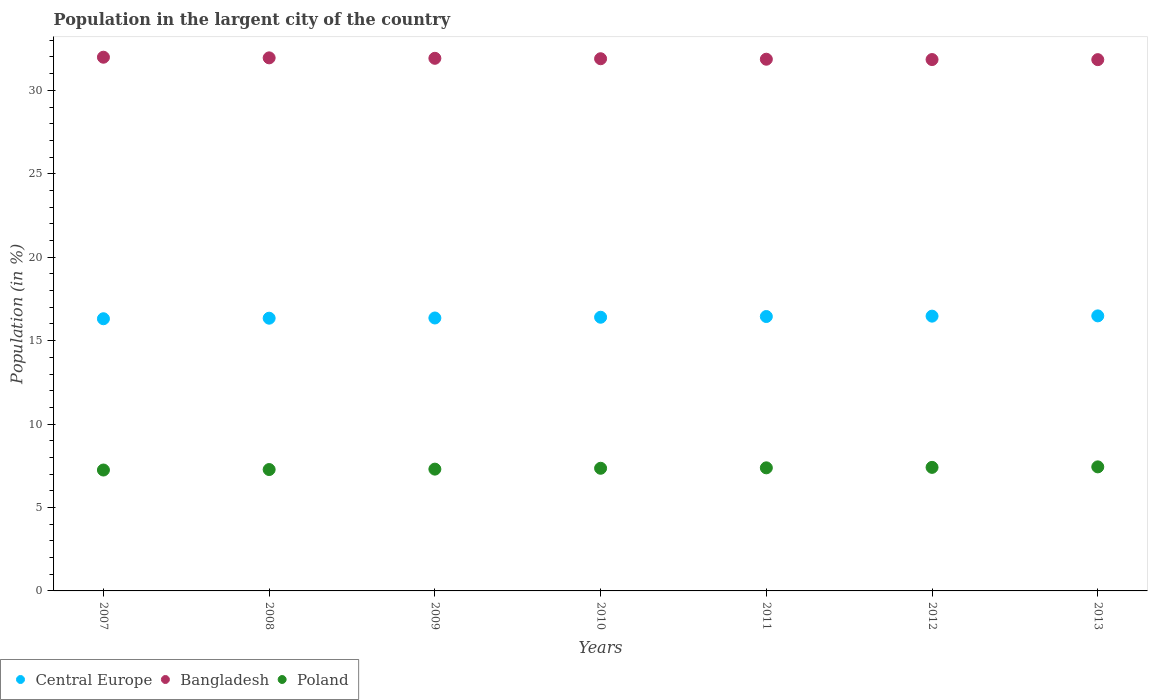How many different coloured dotlines are there?
Provide a short and direct response. 3. What is the percentage of population in the largent city in Poland in 2013?
Make the answer very short. 7.43. Across all years, what is the maximum percentage of population in the largent city in Poland?
Your answer should be compact. 7.43. Across all years, what is the minimum percentage of population in the largent city in Poland?
Provide a succinct answer. 7.25. In which year was the percentage of population in the largent city in Poland maximum?
Ensure brevity in your answer.  2013. In which year was the percentage of population in the largent city in Poland minimum?
Provide a short and direct response. 2007. What is the total percentage of population in the largent city in Bangladesh in the graph?
Provide a short and direct response. 223.3. What is the difference between the percentage of population in the largent city in Bangladesh in 2007 and that in 2012?
Provide a succinct answer. 0.14. What is the difference between the percentage of population in the largent city in Central Europe in 2013 and the percentage of population in the largent city in Bangladesh in 2012?
Provide a short and direct response. -15.36. What is the average percentage of population in the largent city in Bangladesh per year?
Your response must be concise. 31.9. In the year 2011, what is the difference between the percentage of population in the largent city in Bangladesh and percentage of population in the largent city in Central Europe?
Give a very brief answer. 15.42. What is the ratio of the percentage of population in the largent city in Poland in 2009 to that in 2011?
Ensure brevity in your answer.  0.99. What is the difference between the highest and the second highest percentage of population in the largent city in Central Europe?
Provide a succinct answer. 0.02. What is the difference between the highest and the lowest percentage of population in the largent city in Central Europe?
Provide a short and direct response. 0.17. Is it the case that in every year, the sum of the percentage of population in the largent city in Bangladesh and percentage of population in the largent city in Central Europe  is greater than the percentage of population in the largent city in Poland?
Keep it short and to the point. Yes. Is the percentage of population in the largent city in Poland strictly greater than the percentage of population in the largent city in Central Europe over the years?
Your response must be concise. No. Is the percentage of population in the largent city in Central Europe strictly less than the percentage of population in the largent city in Poland over the years?
Provide a succinct answer. No. What is the difference between two consecutive major ticks on the Y-axis?
Offer a terse response. 5. Are the values on the major ticks of Y-axis written in scientific E-notation?
Offer a terse response. No. Does the graph contain any zero values?
Provide a succinct answer. No. Does the graph contain grids?
Provide a short and direct response. No. How many legend labels are there?
Make the answer very short. 3. How are the legend labels stacked?
Ensure brevity in your answer.  Horizontal. What is the title of the graph?
Give a very brief answer. Population in the largent city of the country. What is the label or title of the Y-axis?
Give a very brief answer. Population (in %). What is the Population (in %) in Central Europe in 2007?
Give a very brief answer. 16.31. What is the Population (in %) in Bangladesh in 2007?
Your response must be concise. 31.99. What is the Population (in %) of Poland in 2007?
Provide a succinct answer. 7.25. What is the Population (in %) in Central Europe in 2008?
Provide a short and direct response. 16.34. What is the Population (in %) of Bangladesh in 2008?
Your answer should be very brief. 31.95. What is the Population (in %) of Poland in 2008?
Make the answer very short. 7.27. What is the Population (in %) in Central Europe in 2009?
Offer a terse response. 16.36. What is the Population (in %) in Bangladesh in 2009?
Your answer should be compact. 31.92. What is the Population (in %) of Poland in 2009?
Provide a short and direct response. 7.3. What is the Population (in %) in Central Europe in 2010?
Keep it short and to the point. 16.4. What is the Population (in %) in Bangladesh in 2010?
Provide a short and direct response. 31.89. What is the Population (in %) of Poland in 2010?
Provide a short and direct response. 7.35. What is the Population (in %) of Central Europe in 2011?
Offer a very short reply. 16.45. What is the Population (in %) of Bangladesh in 2011?
Keep it short and to the point. 31.87. What is the Population (in %) in Poland in 2011?
Ensure brevity in your answer.  7.38. What is the Population (in %) in Central Europe in 2012?
Your response must be concise. 16.47. What is the Population (in %) of Bangladesh in 2012?
Give a very brief answer. 31.85. What is the Population (in %) of Poland in 2012?
Your response must be concise. 7.4. What is the Population (in %) in Central Europe in 2013?
Keep it short and to the point. 16.48. What is the Population (in %) of Bangladesh in 2013?
Provide a succinct answer. 31.84. What is the Population (in %) of Poland in 2013?
Keep it short and to the point. 7.43. Across all years, what is the maximum Population (in %) in Central Europe?
Keep it short and to the point. 16.48. Across all years, what is the maximum Population (in %) in Bangladesh?
Make the answer very short. 31.99. Across all years, what is the maximum Population (in %) of Poland?
Your answer should be compact. 7.43. Across all years, what is the minimum Population (in %) in Central Europe?
Offer a terse response. 16.31. Across all years, what is the minimum Population (in %) in Bangladesh?
Keep it short and to the point. 31.84. Across all years, what is the minimum Population (in %) in Poland?
Keep it short and to the point. 7.25. What is the total Population (in %) of Central Europe in the graph?
Make the answer very short. 114.81. What is the total Population (in %) of Bangladesh in the graph?
Offer a very short reply. 223.3. What is the total Population (in %) in Poland in the graph?
Your answer should be very brief. 51.38. What is the difference between the Population (in %) of Central Europe in 2007 and that in 2008?
Keep it short and to the point. -0.03. What is the difference between the Population (in %) of Bangladesh in 2007 and that in 2008?
Offer a very short reply. 0.04. What is the difference between the Population (in %) in Poland in 2007 and that in 2008?
Provide a short and direct response. -0.03. What is the difference between the Population (in %) in Central Europe in 2007 and that in 2009?
Offer a terse response. -0.05. What is the difference between the Population (in %) in Bangladesh in 2007 and that in 2009?
Your answer should be very brief. 0.07. What is the difference between the Population (in %) of Poland in 2007 and that in 2009?
Offer a terse response. -0.05. What is the difference between the Population (in %) in Central Europe in 2007 and that in 2010?
Give a very brief answer. -0.09. What is the difference between the Population (in %) in Bangladesh in 2007 and that in 2010?
Provide a succinct answer. 0.09. What is the difference between the Population (in %) in Poland in 2007 and that in 2010?
Keep it short and to the point. -0.1. What is the difference between the Population (in %) of Central Europe in 2007 and that in 2011?
Provide a short and direct response. -0.13. What is the difference between the Population (in %) in Bangladesh in 2007 and that in 2011?
Your response must be concise. 0.12. What is the difference between the Population (in %) of Poland in 2007 and that in 2011?
Your answer should be compact. -0.13. What is the difference between the Population (in %) of Central Europe in 2007 and that in 2012?
Keep it short and to the point. -0.16. What is the difference between the Population (in %) in Bangladesh in 2007 and that in 2012?
Make the answer very short. 0.14. What is the difference between the Population (in %) in Poland in 2007 and that in 2012?
Your answer should be compact. -0.16. What is the difference between the Population (in %) of Central Europe in 2007 and that in 2013?
Give a very brief answer. -0.17. What is the difference between the Population (in %) in Bangladesh in 2007 and that in 2013?
Your answer should be very brief. 0.15. What is the difference between the Population (in %) of Poland in 2007 and that in 2013?
Offer a very short reply. -0.19. What is the difference between the Population (in %) in Central Europe in 2008 and that in 2009?
Make the answer very short. -0.01. What is the difference between the Population (in %) in Bangladesh in 2008 and that in 2009?
Make the answer very short. 0.03. What is the difference between the Population (in %) in Poland in 2008 and that in 2009?
Your answer should be compact. -0.02. What is the difference between the Population (in %) of Central Europe in 2008 and that in 2010?
Your answer should be compact. -0.06. What is the difference between the Population (in %) of Bangladesh in 2008 and that in 2010?
Make the answer very short. 0.05. What is the difference between the Population (in %) of Poland in 2008 and that in 2010?
Your response must be concise. -0.08. What is the difference between the Population (in %) in Central Europe in 2008 and that in 2011?
Your answer should be compact. -0.1. What is the difference between the Population (in %) of Bangladesh in 2008 and that in 2011?
Offer a terse response. 0.08. What is the difference between the Population (in %) in Poland in 2008 and that in 2011?
Provide a short and direct response. -0.1. What is the difference between the Population (in %) of Central Europe in 2008 and that in 2012?
Make the answer very short. -0.12. What is the difference between the Population (in %) of Bangladesh in 2008 and that in 2012?
Offer a terse response. 0.1. What is the difference between the Population (in %) of Poland in 2008 and that in 2012?
Ensure brevity in your answer.  -0.13. What is the difference between the Population (in %) in Central Europe in 2008 and that in 2013?
Your answer should be compact. -0.14. What is the difference between the Population (in %) in Bangladesh in 2008 and that in 2013?
Give a very brief answer. 0.11. What is the difference between the Population (in %) of Poland in 2008 and that in 2013?
Give a very brief answer. -0.16. What is the difference between the Population (in %) in Central Europe in 2009 and that in 2010?
Give a very brief answer. -0.04. What is the difference between the Population (in %) of Bangladesh in 2009 and that in 2010?
Provide a succinct answer. 0.03. What is the difference between the Population (in %) of Poland in 2009 and that in 2010?
Offer a terse response. -0.05. What is the difference between the Population (in %) of Central Europe in 2009 and that in 2011?
Give a very brief answer. -0.09. What is the difference between the Population (in %) of Bangladesh in 2009 and that in 2011?
Make the answer very short. 0.05. What is the difference between the Population (in %) of Poland in 2009 and that in 2011?
Your response must be concise. -0.08. What is the difference between the Population (in %) of Central Europe in 2009 and that in 2012?
Offer a terse response. -0.11. What is the difference between the Population (in %) in Bangladesh in 2009 and that in 2012?
Your response must be concise. 0.08. What is the difference between the Population (in %) in Poland in 2009 and that in 2012?
Offer a terse response. -0.11. What is the difference between the Population (in %) in Central Europe in 2009 and that in 2013?
Offer a terse response. -0.13. What is the difference between the Population (in %) in Bangladesh in 2009 and that in 2013?
Give a very brief answer. 0.08. What is the difference between the Population (in %) in Poland in 2009 and that in 2013?
Ensure brevity in your answer.  -0.14. What is the difference between the Population (in %) of Central Europe in 2010 and that in 2011?
Keep it short and to the point. -0.04. What is the difference between the Population (in %) of Bangladesh in 2010 and that in 2011?
Keep it short and to the point. 0.03. What is the difference between the Population (in %) in Poland in 2010 and that in 2011?
Provide a succinct answer. -0.03. What is the difference between the Population (in %) of Central Europe in 2010 and that in 2012?
Keep it short and to the point. -0.07. What is the difference between the Population (in %) of Bangladesh in 2010 and that in 2012?
Provide a short and direct response. 0.05. What is the difference between the Population (in %) in Poland in 2010 and that in 2012?
Your answer should be very brief. -0.05. What is the difference between the Population (in %) of Central Europe in 2010 and that in 2013?
Give a very brief answer. -0.08. What is the difference between the Population (in %) in Bangladesh in 2010 and that in 2013?
Offer a very short reply. 0.05. What is the difference between the Population (in %) in Poland in 2010 and that in 2013?
Your response must be concise. -0.08. What is the difference between the Population (in %) of Central Europe in 2011 and that in 2012?
Offer a terse response. -0.02. What is the difference between the Population (in %) in Bangladesh in 2011 and that in 2012?
Your answer should be very brief. 0.02. What is the difference between the Population (in %) of Poland in 2011 and that in 2012?
Provide a succinct answer. -0.03. What is the difference between the Population (in %) of Central Europe in 2011 and that in 2013?
Make the answer very short. -0.04. What is the difference between the Population (in %) of Bangladesh in 2011 and that in 2013?
Make the answer very short. 0.03. What is the difference between the Population (in %) in Poland in 2011 and that in 2013?
Your answer should be very brief. -0.06. What is the difference between the Population (in %) of Central Europe in 2012 and that in 2013?
Offer a very short reply. -0.02. What is the difference between the Population (in %) in Bangladesh in 2012 and that in 2013?
Ensure brevity in your answer.  0.01. What is the difference between the Population (in %) of Poland in 2012 and that in 2013?
Give a very brief answer. -0.03. What is the difference between the Population (in %) in Central Europe in 2007 and the Population (in %) in Bangladesh in 2008?
Your answer should be compact. -15.63. What is the difference between the Population (in %) in Central Europe in 2007 and the Population (in %) in Poland in 2008?
Your answer should be compact. 9.04. What is the difference between the Population (in %) in Bangladesh in 2007 and the Population (in %) in Poland in 2008?
Keep it short and to the point. 24.71. What is the difference between the Population (in %) of Central Europe in 2007 and the Population (in %) of Bangladesh in 2009?
Offer a terse response. -15.61. What is the difference between the Population (in %) of Central Europe in 2007 and the Population (in %) of Poland in 2009?
Provide a succinct answer. 9.01. What is the difference between the Population (in %) in Bangladesh in 2007 and the Population (in %) in Poland in 2009?
Provide a short and direct response. 24.69. What is the difference between the Population (in %) in Central Europe in 2007 and the Population (in %) in Bangladesh in 2010?
Ensure brevity in your answer.  -15.58. What is the difference between the Population (in %) in Central Europe in 2007 and the Population (in %) in Poland in 2010?
Provide a short and direct response. 8.96. What is the difference between the Population (in %) in Bangladesh in 2007 and the Population (in %) in Poland in 2010?
Keep it short and to the point. 24.64. What is the difference between the Population (in %) in Central Europe in 2007 and the Population (in %) in Bangladesh in 2011?
Offer a terse response. -15.55. What is the difference between the Population (in %) in Central Europe in 2007 and the Population (in %) in Poland in 2011?
Make the answer very short. 8.94. What is the difference between the Population (in %) of Bangladesh in 2007 and the Population (in %) of Poland in 2011?
Your answer should be compact. 24.61. What is the difference between the Population (in %) of Central Europe in 2007 and the Population (in %) of Bangladesh in 2012?
Your answer should be compact. -15.53. What is the difference between the Population (in %) in Central Europe in 2007 and the Population (in %) in Poland in 2012?
Give a very brief answer. 8.91. What is the difference between the Population (in %) of Bangladesh in 2007 and the Population (in %) of Poland in 2012?
Offer a very short reply. 24.58. What is the difference between the Population (in %) in Central Europe in 2007 and the Population (in %) in Bangladesh in 2013?
Provide a short and direct response. -15.53. What is the difference between the Population (in %) of Central Europe in 2007 and the Population (in %) of Poland in 2013?
Ensure brevity in your answer.  8.88. What is the difference between the Population (in %) in Bangladesh in 2007 and the Population (in %) in Poland in 2013?
Ensure brevity in your answer.  24.55. What is the difference between the Population (in %) in Central Europe in 2008 and the Population (in %) in Bangladesh in 2009?
Give a very brief answer. -15.58. What is the difference between the Population (in %) of Central Europe in 2008 and the Population (in %) of Poland in 2009?
Ensure brevity in your answer.  9.05. What is the difference between the Population (in %) in Bangladesh in 2008 and the Population (in %) in Poland in 2009?
Offer a terse response. 24.65. What is the difference between the Population (in %) of Central Europe in 2008 and the Population (in %) of Bangladesh in 2010?
Offer a very short reply. -15.55. What is the difference between the Population (in %) of Central Europe in 2008 and the Population (in %) of Poland in 2010?
Give a very brief answer. 8.99. What is the difference between the Population (in %) in Bangladesh in 2008 and the Population (in %) in Poland in 2010?
Give a very brief answer. 24.6. What is the difference between the Population (in %) of Central Europe in 2008 and the Population (in %) of Bangladesh in 2011?
Make the answer very short. -15.52. What is the difference between the Population (in %) of Central Europe in 2008 and the Population (in %) of Poland in 2011?
Provide a succinct answer. 8.97. What is the difference between the Population (in %) of Bangladesh in 2008 and the Population (in %) of Poland in 2011?
Your answer should be compact. 24.57. What is the difference between the Population (in %) in Central Europe in 2008 and the Population (in %) in Bangladesh in 2012?
Your answer should be compact. -15.5. What is the difference between the Population (in %) of Central Europe in 2008 and the Population (in %) of Poland in 2012?
Your answer should be very brief. 8.94. What is the difference between the Population (in %) in Bangladesh in 2008 and the Population (in %) in Poland in 2012?
Provide a short and direct response. 24.54. What is the difference between the Population (in %) of Central Europe in 2008 and the Population (in %) of Bangladesh in 2013?
Offer a very short reply. -15.5. What is the difference between the Population (in %) in Central Europe in 2008 and the Population (in %) in Poland in 2013?
Make the answer very short. 8.91. What is the difference between the Population (in %) in Bangladesh in 2008 and the Population (in %) in Poland in 2013?
Give a very brief answer. 24.51. What is the difference between the Population (in %) in Central Europe in 2009 and the Population (in %) in Bangladesh in 2010?
Keep it short and to the point. -15.54. What is the difference between the Population (in %) in Central Europe in 2009 and the Population (in %) in Poland in 2010?
Your answer should be compact. 9.01. What is the difference between the Population (in %) of Bangladesh in 2009 and the Population (in %) of Poland in 2010?
Keep it short and to the point. 24.57. What is the difference between the Population (in %) in Central Europe in 2009 and the Population (in %) in Bangladesh in 2011?
Keep it short and to the point. -15.51. What is the difference between the Population (in %) in Central Europe in 2009 and the Population (in %) in Poland in 2011?
Keep it short and to the point. 8.98. What is the difference between the Population (in %) in Bangladesh in 2009 and the Population (in %) in Poland in 2011?
Provide a short and direct response. 24.54. What is the difference between the Population (in %) of Central Europe in 2009 and the Population (in %) of Bangladesh in 2012?
Make the answer very short. -15.49. What is the difference between the Population (in %) in Central Europe in 2009 and the Population (in %) in Poland in 2012?
Keep it short and to the point. 8.95. What is the difference between the Population (in %) in Bangladesh in 2009 and the Population (in %) in Poland in 2012?
Provide a succinct answer. 24.52. What is the difference between the Population (in %) of Central Europe in 2009 and the Population (in %) of Bangladesh in 2013?
Offer a terse response. -15.48. What is the difference between the Population (in %) in Central Europe in 2009 and the Population (in %) in Poland in 2013?
Make the answer very short. 8.92. What is the difference between the Population (in %) of Bangladesh in 2009 and the Population (in %) of Poland in 2013?
Make the answer very short. 24.49. What is the difference between the Population (in %) in Central Europe in 2010 and the Population (in %) in Bangladesh in 2011?
Ensure brevity in your answer.  -15.46. What is the difference between the Population (in %) in Central Europe in 2010 and the Population (in %) in Poland in 2011?
Give a very brief answer. 9.03. What is the difference between the Population (in %) in Bangladesh in 2010 and the Population (in %) in Poland in 2011?
Ensure brevity in your answer.  24.52. What is the difference between the Population (in %) in Central Europe in 2010 and the Population (in %) in Bangladesh in 2012?
Offer a very short reply. -15.44. What is the difference between the Population (in %) of Central Europe in 2010 and the Population (in %) of Poland in 2012?
Make the answer very short. 9. What is the difference between the Population (in %) in Bangladesh in 2010 and the Population (in %) in Poland in 2012?
Keep it short and to the point. 24.49. What is the difference between the Population (in %) in Central Europe in 2010 and the Population (in %) in Bangladesh in 2013?
Provide a short and direct response. -15.44. What is the difference between the Population (in %) in Central Europe in 2010 and the Population (in %) in Poland in 2013?
Ensure brevity in your answer.  8.97. What is the difference between the Population (in %) of Bangladesh in 2010 and the Population (in %) of Poland in 2013?
Provide a succinct answer. 24.46. What is the difference between the Population (in %) in Central Europe in 2011 and the Population (in %) in Bangladesh in 2012?
Keep it short and to the point. -15.4. What is the difference between the Population (in %) of Central Europe in 2011 and the Population (in %) of Poland in 2012?
Your answer should be very brief. 9.04. What is the difference between the Population (in %) in Bangladesh in 2011 and the Population (in %) in Poland in 2012?
Your answer should be compact. 24.46. What is the difference between the Population (in %) in Central Europe in 2011 and the Population (in %) in Bangladesh in 2013?
Provide a succinct answer. -15.39. What is the difference between the Population (in %) in Central Europe in 2011 and the Population (in %) in Poland in 2013?
Offer a terse response. 9.01. What is the difference between the Population (in %) in Bangladesh in 2011 and the Population (in %) in Poland in 2013?
Your answer should be very brief. 24.43. What is the difference between the Population (in %) in Central Europe in 2012 and the Population (in %) in Bangladesh in 2013?
Provide a short and direct response. -15.37. What is the difference between the Population (in %) in Central Europe in 2012 and the Population (in %) in Poland in 2013?
Ensure brevity in your answer.  9.03. What is the difference between the Population (in %) in Bangladesh in 2012 and the Population (in %) in Poland in 2013?
Provide a succinct answer. 24.41. What is the average Population (in %) of Central Europe per year?
Provide a short and direct response. 16.4. What is the average Population (in %) of Bangladesh per year?
Provide a succinct answer. 31.9. What is the average Population (in %) in Poland per year?
Provide a succinct answer. 7.34. In the year 2007, what is the difference between the Population (in %) in Central Europe and Population (in %) in Bangladesh?
Your answer should be compact. -15.67. In the year 2007, what is the difference between the Population (in %) in Central Europe and Population (in %) in Poland?
Provide a short and direct response. 9.07. In the year 2007, what is the difference between the Population (in %) in Bangladesh and Population (in %) in Poland?
Provide a succinct answer. 24.74. In the year 2008, what is the difference between the Population (in %) of Central Europe and Population (in %) of Bangladesh?
Make the answer very short. -15.6. In the year 2008, what is the difference between the Population (in %) in Central Europe and Population (in %) in Poland?
Provide a succinct answer. 9.07. In the year 2008, what is the difference between the Population (in %) in Bangladesh and Population (in %) in Poland?
Your answer should be compact. 24.67. In the year 2009, what is the difference between the Population (in %) of Central Europe and Population (in %) of Bangladesh?
Keep it short and to the point. -15.56. In the year 2009, what is the difference between the Population (in %) of Central Europe and Population (in %) of Poland?
Your answer should be compact. 9.06. In the year 2009, what is the difference between the Population (in %) of Bangladesh and Population (in %) of Poland?
Make the answer very short. 24.62. In the year 2010, what is the difference between the Population (in %) in Central Europe and Population (in %) in Bangladesh?
Ensure brevity in your answer.  -15.49. In the year 2010, what is the difference between the Population (in %) of Central Europe and Population (in %) of Poland?
Provide a succinct answer. 9.05. In the year 2010, what is the difference between the Population (in %) in Bangladesh and Population (in %) in Poland?
Ensure brevity in your answer.  24.54. In the year 2011, what is the difference between the Population (in %) in Central Europe and Population (in %) in Bangladesh?
Keep it short and to the point. -15.42. In the year 2011, what is the difference between the Population (in %) of Central Europe and Population (in %) of Poland?
Ensure brevity in your answer.  9.07. In the year 2011, what is the difference between the Population (in %) of Bangladesh and Population (in %) of Poland?
Give a very brief answer. 24.49. In the year 2012, what is the difference between the Population (in %) in Central Europe and Population (in %) in Bangladesh?
Your answer should be compact. -15.38. In the year 2012, what is the difference between the Population (in %) in Central Europe and Population (in %) in Poland?
Your answer should be compact. 9.06. In the year 2012, what is the difference between the Population (in %) in Bangladesh and Population (in %) in Poland?
Your answer should be very brief. 24.44. In the year 2013, what is the difference between the Population (in %) in Central Europe and Population (in %) in Bangladesh?
Give a very brief answer. -15.36. In the year 2013, what is the difference between the Population (in %) in Central Europe and Population (in %) in Poland?
Your answer should be compact. 9.05. In the year 2013, what is the difference between the Population (in %) of Bangladesh and Population (in %) of Poland?
Ensure brevity in your answer.  24.41. What is the ratio of the Population (in %) of Bangladesh in 2007 to that in 2008?
Give a very brief answer. 1. What is the ratio of the Population (in %) in Central Europe in 2007 to that in 2009?
Make the answer very short. 1. What is the ratio of the Population (in %) in Bangladesh in 2007 to that in 2009?
Offer a very short reply. 1. What is the ratio of the Population (in %) of Poland in 2007 to that in 2009?
Ensure brevity in your answer.  0.99. What is the ratio of the Population (in %) of Central Europe in 2007 to that in 2010?
Your answer should be very brief. 0.99. What is the ratio of the Population (in %) in Bangladesh in 2007 to that in 2010?
Ensure brevity in your answer.  1. What is the ratio of the Population (in %) of Poland in 2007 to that in 2010?
Your answer should be compact. 0.99. What is the ratio of the Population (in %) in Central Europe in 2007 to that in 2011?
Offer a very short reply. 0.99. What is the ratio of the Population (in %) in Poland in 2007 to that in 2011?
Give a very brief answer. 0.98. What is the ratio of the Population (in %) of Central Europe in 2007 to that in 2012?
Give a very brief answer. 0.99. What is the ratio of the Population (in %) of Poland in 2007 to that in 2012?
Ensure brevity in your answer.  0.98. What is the ratio of the Population (in %) in Central Europe in 2007 to that in 2013?
Keep it short and to the point. 0.99. What is the ratio of the Population (in %) in Poland in 2007 to that in 2013?
Ensure brevity in your answer.  0.97. What is the ratio of the Population (in %) in Central Europe in 2008 to that in 2009?
Ensure brevity in your answer.  1. What is the ratio of the Population (in %) of Bangladesh in 2008 to that in 2009?
Keep it short and to the point. 1. What is the ratio of the Population (in %) in Poland in 2008 to that in 2009?
Your answer should be compact. 1. What is the ratio of the Population (in %) of Bangladesh in 2008 to that in 2010?
Your answer should be very brief. 1. What is the ratio of the Population (in %) in Central Europe in 2008 to that in 2011?
Your answer should be compact. 0.99. What is the ratio of the Population (in %) of Bangladesh in 2008 to that in 2011?
Give a very brief answer. 1. What is the ratio of the Population (in %) of Poland in 2008 to that in 2011?
Ensure brevity in your answer.  0.99. What is the ratio of the Population (in %) in Poland in 2008 to that in 2012?
Ensure brevity in your answer.  0.98. What is the ratio of the Population (in %) in Central Europe in 2008 to that in 2013?
Provide a short and direct response. 0.99. What is the ratio of the Population (in %) of Bangladesh in 2008 to that in 2013?
Offer a very short reply. 1. What is the ratio of the Population (in %) of Poland in 2008 to that in 2013?
Offer a very short reply. 0.98. What is the ratio of the Population (in %) of Bangladesh in 2009 to that in 2010?
Make the answer very short. 1. What is the ratio of the Population (in %) in Central Europe in 2009 to that in 2011?
Offer a terse response. 0.99. What is the ratio of the Population (in %) in Bangladesh in 2009 to that in 2011?
Make the answer very short. 1. What is the ratio of the Population (in %) in Bangladesh in 2009 to that in 2012?
Give a very brief answer. 1. What is the ratio of the Population (in %) of Poland in 2009 to that in 2012?
Offer a very short reply. 0.99. What is the ratio of the Population (in %) in Bangladesh in 2009 to that in 2013?
Your response must be concise. 1. What is the ratio of the Population (in %) in Poland in 2009 to that in 2013?
Provide a short and direct response. 0.98. What is the ratio of the Population (in %) in Bangladesh in 2010 to that in 2011?
Provide a short and direct response. 1. What is the ratio of the Population (in %) of Bangladesh in 2010 to that in 2012?
Make the answer very short. 1. What is the ratio of the Population (in %) in Poland in 2010 to that in 2012?
Your response must be concise. 0.99. What is the ratio of the Population (in %) of Central Europe in 2010 to that in 2013?
Offer a terse response. 1. What is the ratio of the Population (in %) of Bangladesh in 2010 to that in 2013?
Ensure brevity in your answer.  1. What is the ratio of the Population (in %) of Poland in 2010 to that in 2013?
Your response must be concise. 0.99. What is the ratio of the Population (in %) of Central Europe in 2011 to that in 2013?
Provide a short and direct response. 1. What is the ratio of the Population (in %) in Bangladesh in 2012 to that in 2013?
Offer a terse response. 1. What is the difference between the highest and the second highest Population (in %) of Central Europe?
Offer a very short reply. 0.02. What is the difference between the highest and the second highest Population (in %) in Bangladesh?
Your answer should be compact. 0.04. What is the difference between the highest and the lowest Population (in %) of Central Europe?
Your answer should be compact. 0.17. What is the difference between the highest and the lowest Population (in %) of Bangladesh?
Offer a very short reply. 0.15. What is the difference between the highest and the lowest Population (in %) in Poland?
Offer a very short reply. 0.19. 